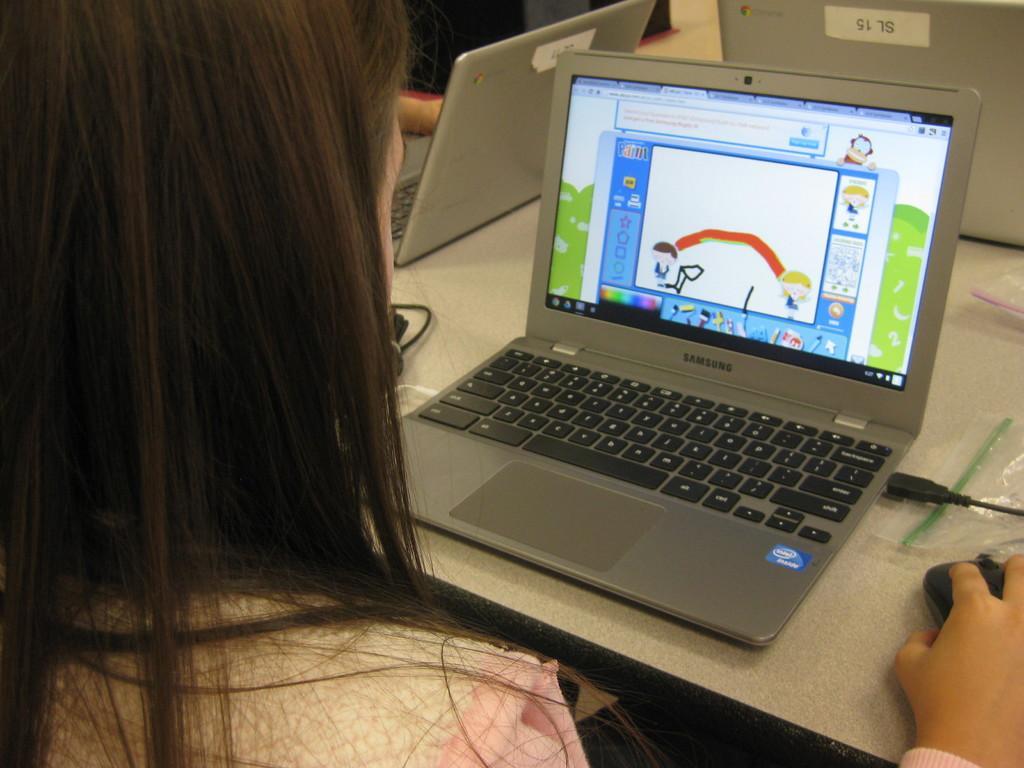Can you describe this image briefly? In this image we can see a woman looking at a laptop placed on the table holding a mouse in her hand. In the background, we can see a hand of a person, laptops, cables and covers placed on the table. 